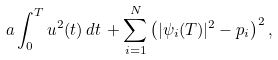<formula> <loc_0><loc_0><loc_500><loc_500>a \int _ { 0 } ^ { T } u ^ { 2 } ( t ) \, d t \, + \sum _ { i = 1 } ^ { N } \left ( | \psi _ { i } ( T ) | ^ { 2 } - p _ { i } \right ) ^ { 2 } ,</formula> 